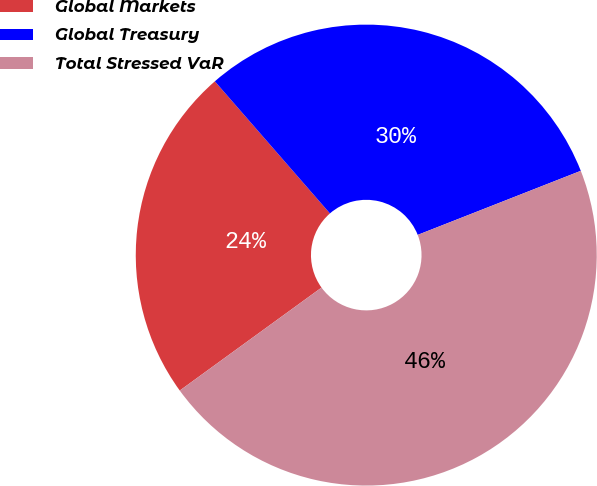Convert chart to OTSL. <chart><loc_0><loc_0><loc_500><loc_500><pie_chart><fcel>Global Markets<fcel>Global Treasury<fcel>Total Stressed VaR<nl><fcel>23.59%<fcel>30.45%<fcel>45.96%<nl></chart> 